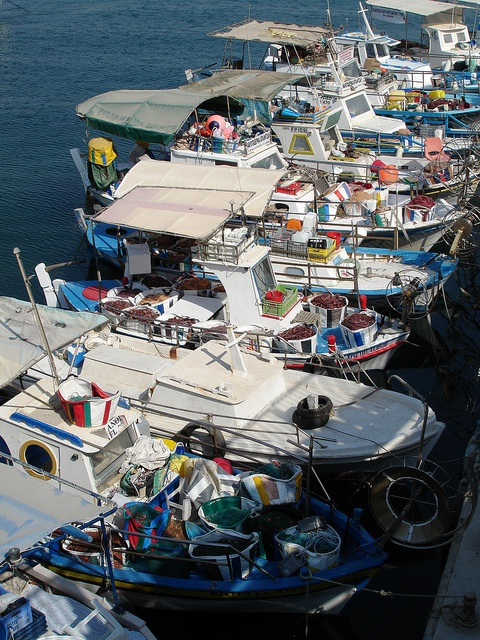Describe the objects in this image and their specific colors. I can see boat in gray, black, darkgray, and lightgray tones, boat in gray, lightgray, darkgray, and black tones, boat in gray, lightgray, black, and darkgray tones, boat in gray, lightgray, black, and darkgray tones, and boat in gray, lightgray, darkgray, and black tones in this image. 